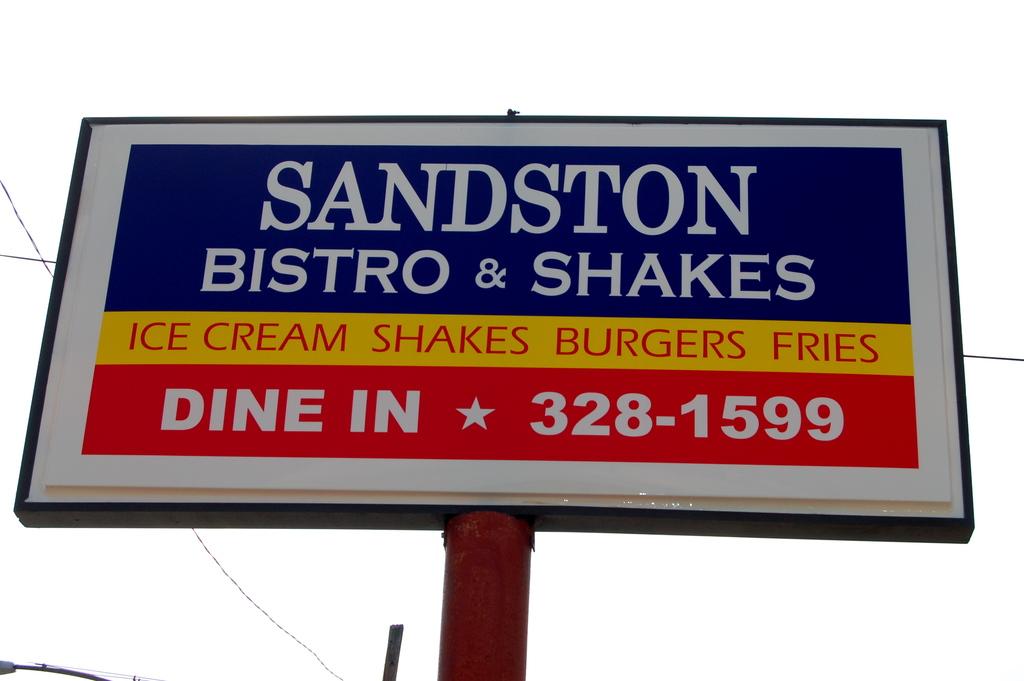Whats the advert about?
Offer a very short reply. Sandston bistro & shakes. 